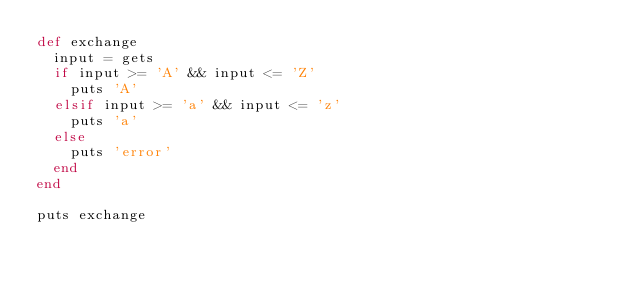<code> <loc_0><loc_0><loc_500><loc_500><_Ruby_>def exchange
  input = gets
  if input >= 'A' && input <= 'Z'
    puts 'A'
  elsif input >= 'a' && input <= 'z'
    puts 'a'
  else
    puts 'error'
  end
end
 
puts exchange</code> 